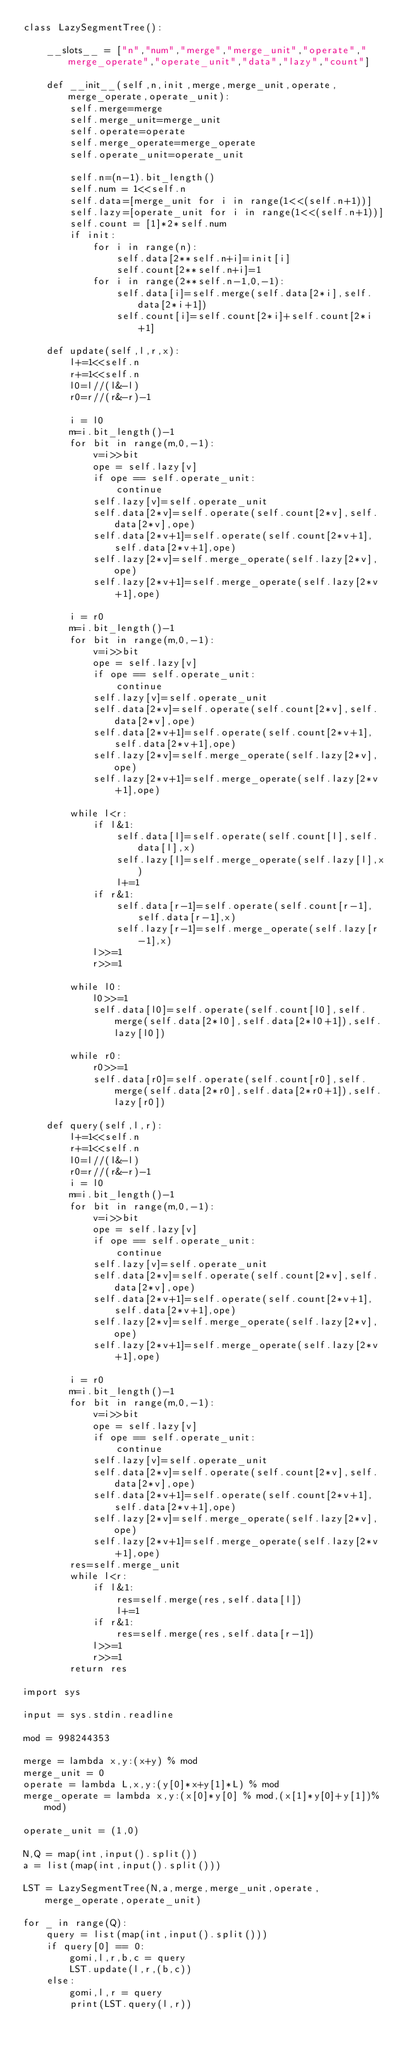<code> <loc_0><loc_0><loc_500><loc_500><_Python_>class LazySegmentTree():

    __slots__ = ["n","num","merge","merge_unit","operate","merge_operate","operate_unit","data","lazy","count"]

    def __init__(self,n,init,merge,merge_unit,operate,merge_operate,operate_unit):
        self.merge=merge
        self.merge_unit=merge_unit
        self.operate=operate
        self.merge_operate=merge_operate
        self.operate_unit=operate_unit

        self.n=(n-1).bit_length()
        self.num = 1<<self.n
        self.data=[merge_unit for i in range(1<<(self.n+1))]
        self.lazy=[operate_unit for i in range(1<<(self.n+1))]
        self.count = [1]*2*self.num
        if init:
            for i in range(n):
                self.data[2**self.n+i]=init[i]
                self.count[2**self.n+i]=1
            for i in range(2**self.n-1,0,-1):
                self.data[i]=self.merge(self.data[2*i],self.data[2*i+1])
                self.count[i]=self.count[2*i]+self.count[2*i+1]

    def update(self,l,r,x):
        l+=1<<self.n
        r+=1<<self.n
        l0=l//(l&-l)
        r0=r//(r&-r)-1

        i = l0
        m=i.bit_length()-1
        for bit in range(m,0,-1):
            v=i>>bit
            ope = self.lazy[v]
            if ope == self.operate_unit:
                continue
            self.lazy[v]=self.operate_unit
            self.data[2*v]=self.operate(self.count[2*v],self.data[2*v],ope)
            self.data[2*v+1]=self.operate(self.count[2*v+1],self.data[2*v+1],ope)
            self.lazy[2*v]=self.merge_operate(self.lazy[2*v],ope)
            self.lazy[2*v+1]=self.merge_operate(self.lazy[2*v+1],ope)

        i = r0
        m=i.bit_length()-1
        for bit in range(m,0,-1):
            v=i>>bit
            ope = self.lazy[v]
            if ope == self.operate_unit:
                continue
            self.lazy[v]=self.operate_unit
            self.data[2*v]=self.operate(self.count[2*v],self.data[2*v],ope)
            self.data[2*v+1]=self.operate(self.count[2*v+1],self.data[2*v+1],ope)
            self.lazy[2*v]=self.merge_operate(self.lazy[2*v],ope)
            self.lazy[2*v+1]=self.merge_operate(self.lazy[2*v+1],ope)

        while l<r:
            if l&1:
                self.data[l]=self.operate(self.count[l],self.data[l],x)
                self.lazy[l]=self.merge_operate(self.lazy[l],x)
                l+=1
            if r&1:
                self.data[r-1]=self.operate(self.count[r-1],self.data[r-1],x)
                self.lazy[r-1]=self.merge_operate(self.lazy[r-1],x)
            l>>=1
            r>>=1

        while l0:
            l0>>=1
            self.data[l0]=self.operate(self.count[l0],self.merge(self.data[2*l0],self.data[2*l0+1]),self.lazy[l0])

        while r0:
            r0>>=1
            self.data[r0]=self.operate(self.count[r0],self.merge(self.data[2*r0],self.data[2*r0+1]),self.lazy[r0])

    def query(self,l,r):
        l+=1<<self.n
        r+=1<<self.n
        l0=l//(l&-l)
        r0=r//(r&-r)-1
        i = l0
        m=i.bit_length()-1
        for bit in range(m,0,-1):
            v=i>>bit
            ope = self.lazy[v]
            if ope == self.operate_unit:
                continue
            self.lazy[v]=self.operate_unit
            self.data[2*v]=self.operate(self.count[2*v],self.data[2*v],ope)
            self.data[2*v+1]=self.operate(self.count[2*v+1],self.data[2*v+1],ope)
            self.lazy[2*v]=self.merge_operate(self.lazy[2*v],ope)
            self.lazy[2*v+1]=self.merge_operate(self.lazy[2*v+1],ope)

        i = r0
        m=i.bit_length()-1
        for bit in range(m,0,-1):
            v=i>>bit
            ope = self.lazy[v]
            if ope == self.operate_unit:
                continue
            self.lazy[v]=self.operate_unit
            self.data[2*v]=self.operate(self.count[2*v],self.data[2*v],ope)
            self.data[2*v+1]=self.operate(self.count[2*v+1],self.data[2*v+1],ope)
            self.lazy[2*v]=self.merge_operate(self.lazy[2*v],ope)
            self.lazy[2*v+1]=self.merge_operate(self.lazy[2*v+1],ope)
        res=self.merge_unit
        while l<r:
            if l&1:
                res=self.merge(res,self.data[l])
                l+=1
            if r&1:
                res=self.merge(res,self.data[r-1])
            l>>=1
            r>>=1
        return res

import sys

input = sys.stdin.readline

mod = 998244353

merge = lambda x,y:(x+y) % mod
merge_unit = 0
operate = lambda L,x,y:(y[0]*x+y[1]*L) % mod
merge_operate = lambda x,y:(x[0]*y[0] % mod,(x[1]*y[0]+y[1])%mod)

operate_unit = (1,0)

N,Q = map(int,input().split())
a = list(map(int,input().split()))

LST = LazySegmentTree(N,a,merge,merge_unit,operate,merge_operate,operate_unit)

for _ in range(Q):
    query = list(map(int,input().split()))
    if query[0] == 0:
        gomi,l,r,b,c = query
        LST.update(l,r,(b,c))
    else:
        gomi,l,r = query
        print(LST.query(l,r))</code> 